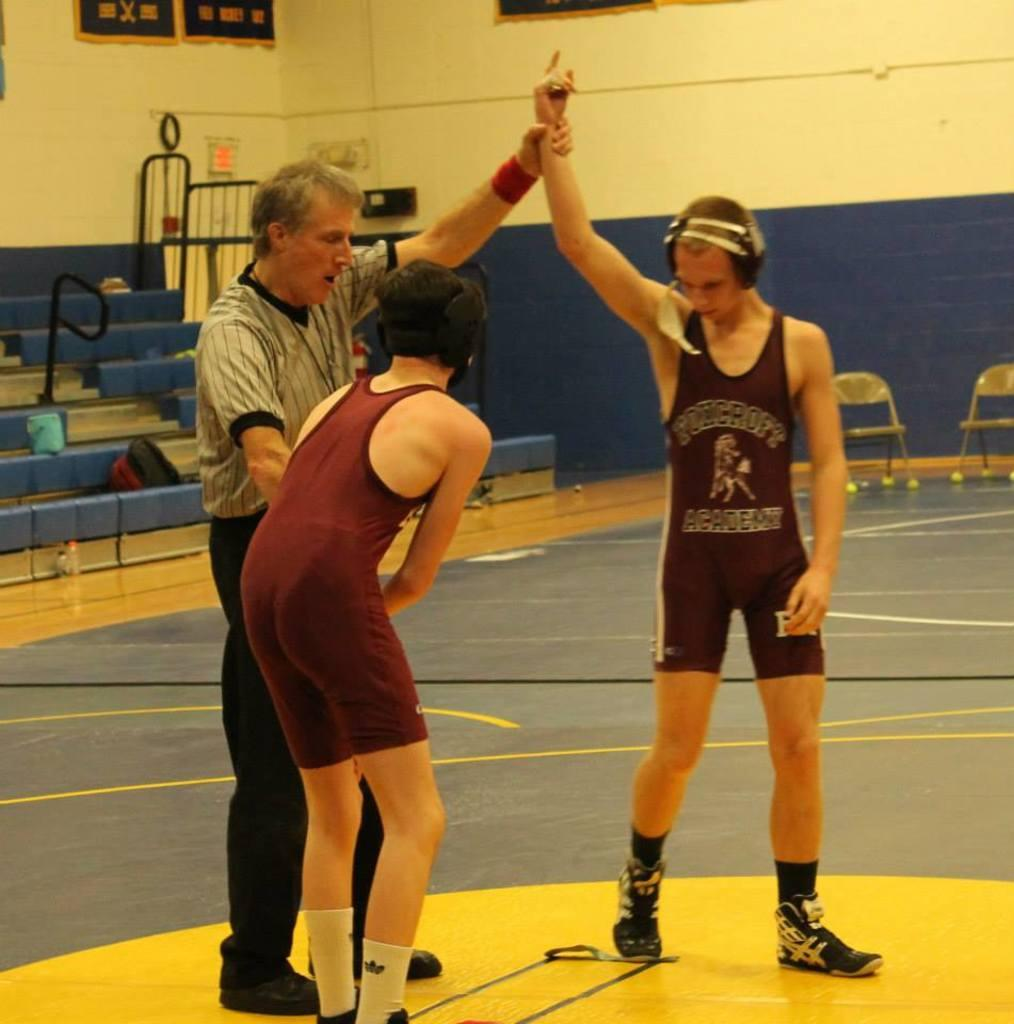<image>
Render a clear and concise summary of the photo. The two boys wear the same clothing from an academy. 